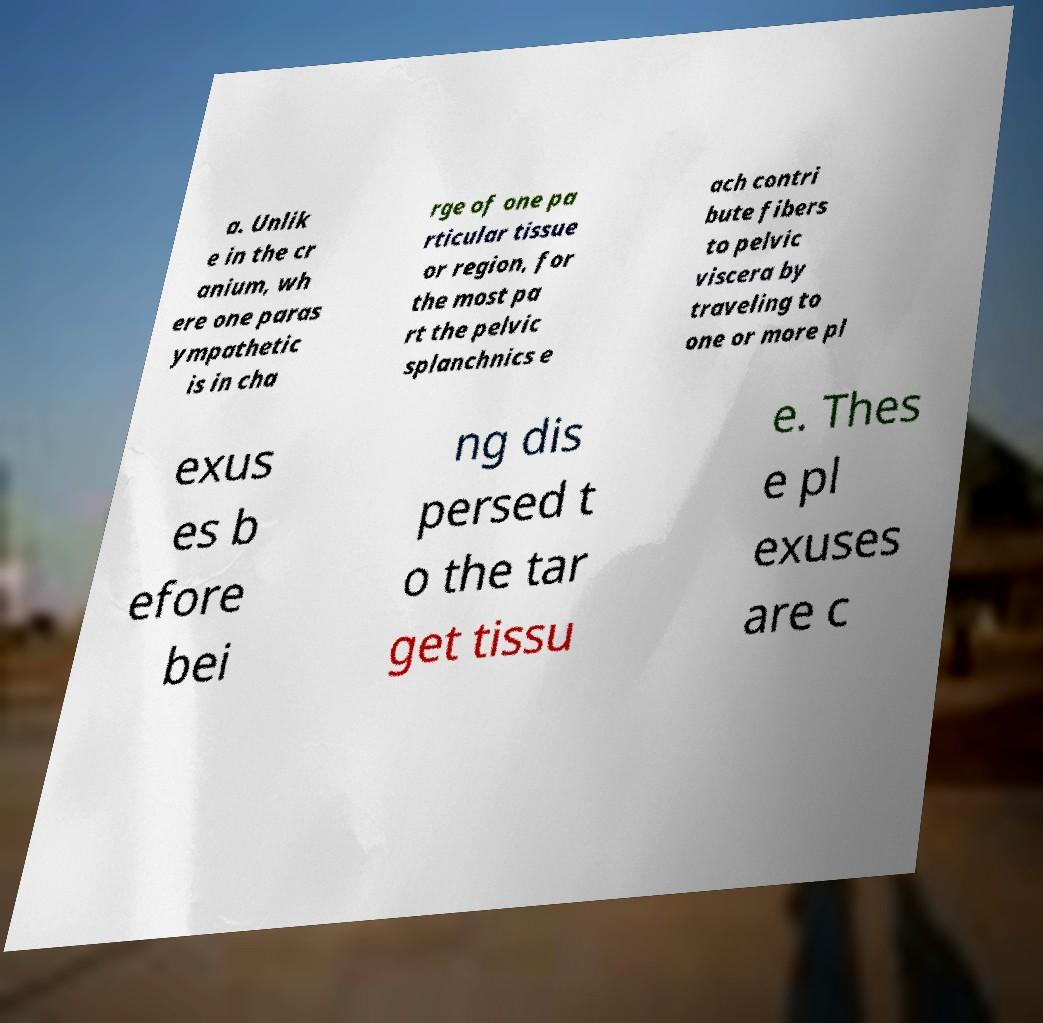There's text embedded in this image that I need extracted. Can you transcribe it verbatim? a. Unlik e in the cr anium, wh ere one paras ympathetic is in cha rge of one pa rticular tissue or region, for the most pa rt the pelvic splanchnics e ach contri bute fibers to pelvic viscera by traveling to one or more pl exus es b efore bei ng dis persed t o the tar get tissu e. Thes e pl exuses are c 